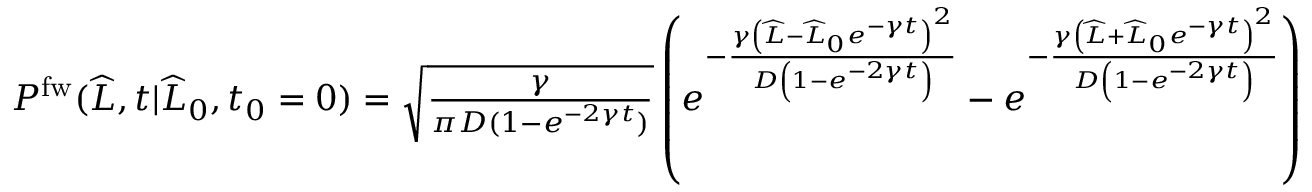Convert formula to latex. <formula><loc_0><loc_0><loc_500><loc_500>\begin{array} { r } { P ^ { f w } ( \widehat { L } , t | \widehat { L } _ { 0 } , t _ { 0 } = 0 ) = \sqrt { \frac { \gamma } { \pi D ( 1 - e ^ { - 2 \gamma t } ) } } \left ( e ^ { - \frac { \gamma \left ( \widehat { L } - \widehat { L } _ { 0 } e ^ { - \gamma t } \right ) ^ { 2 } } { D \left ( 1 - e ^ { - 2 \gamma t } \right ) } } - e ^ { - \frac { \gamma \left ( \widehat { L } + \widehat { L } _ { 0 } e ^ { - \gamma t } \right ) ^ { 2 } } { D \left ( 1 - e ^ { - 2 \gamma t } \right ) } } \right ) } \end{array}</formula> 